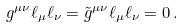<formula> <loc_0><loc_0><loc_500><loc_500>g ^ { \mu \nu } \ell _ { \mu } \ell _ { \nu } = \tilde { g } ^ { \mu \nu } \ell _ { \mu } \ell _ { \nu } = 0 \, .</formula> 